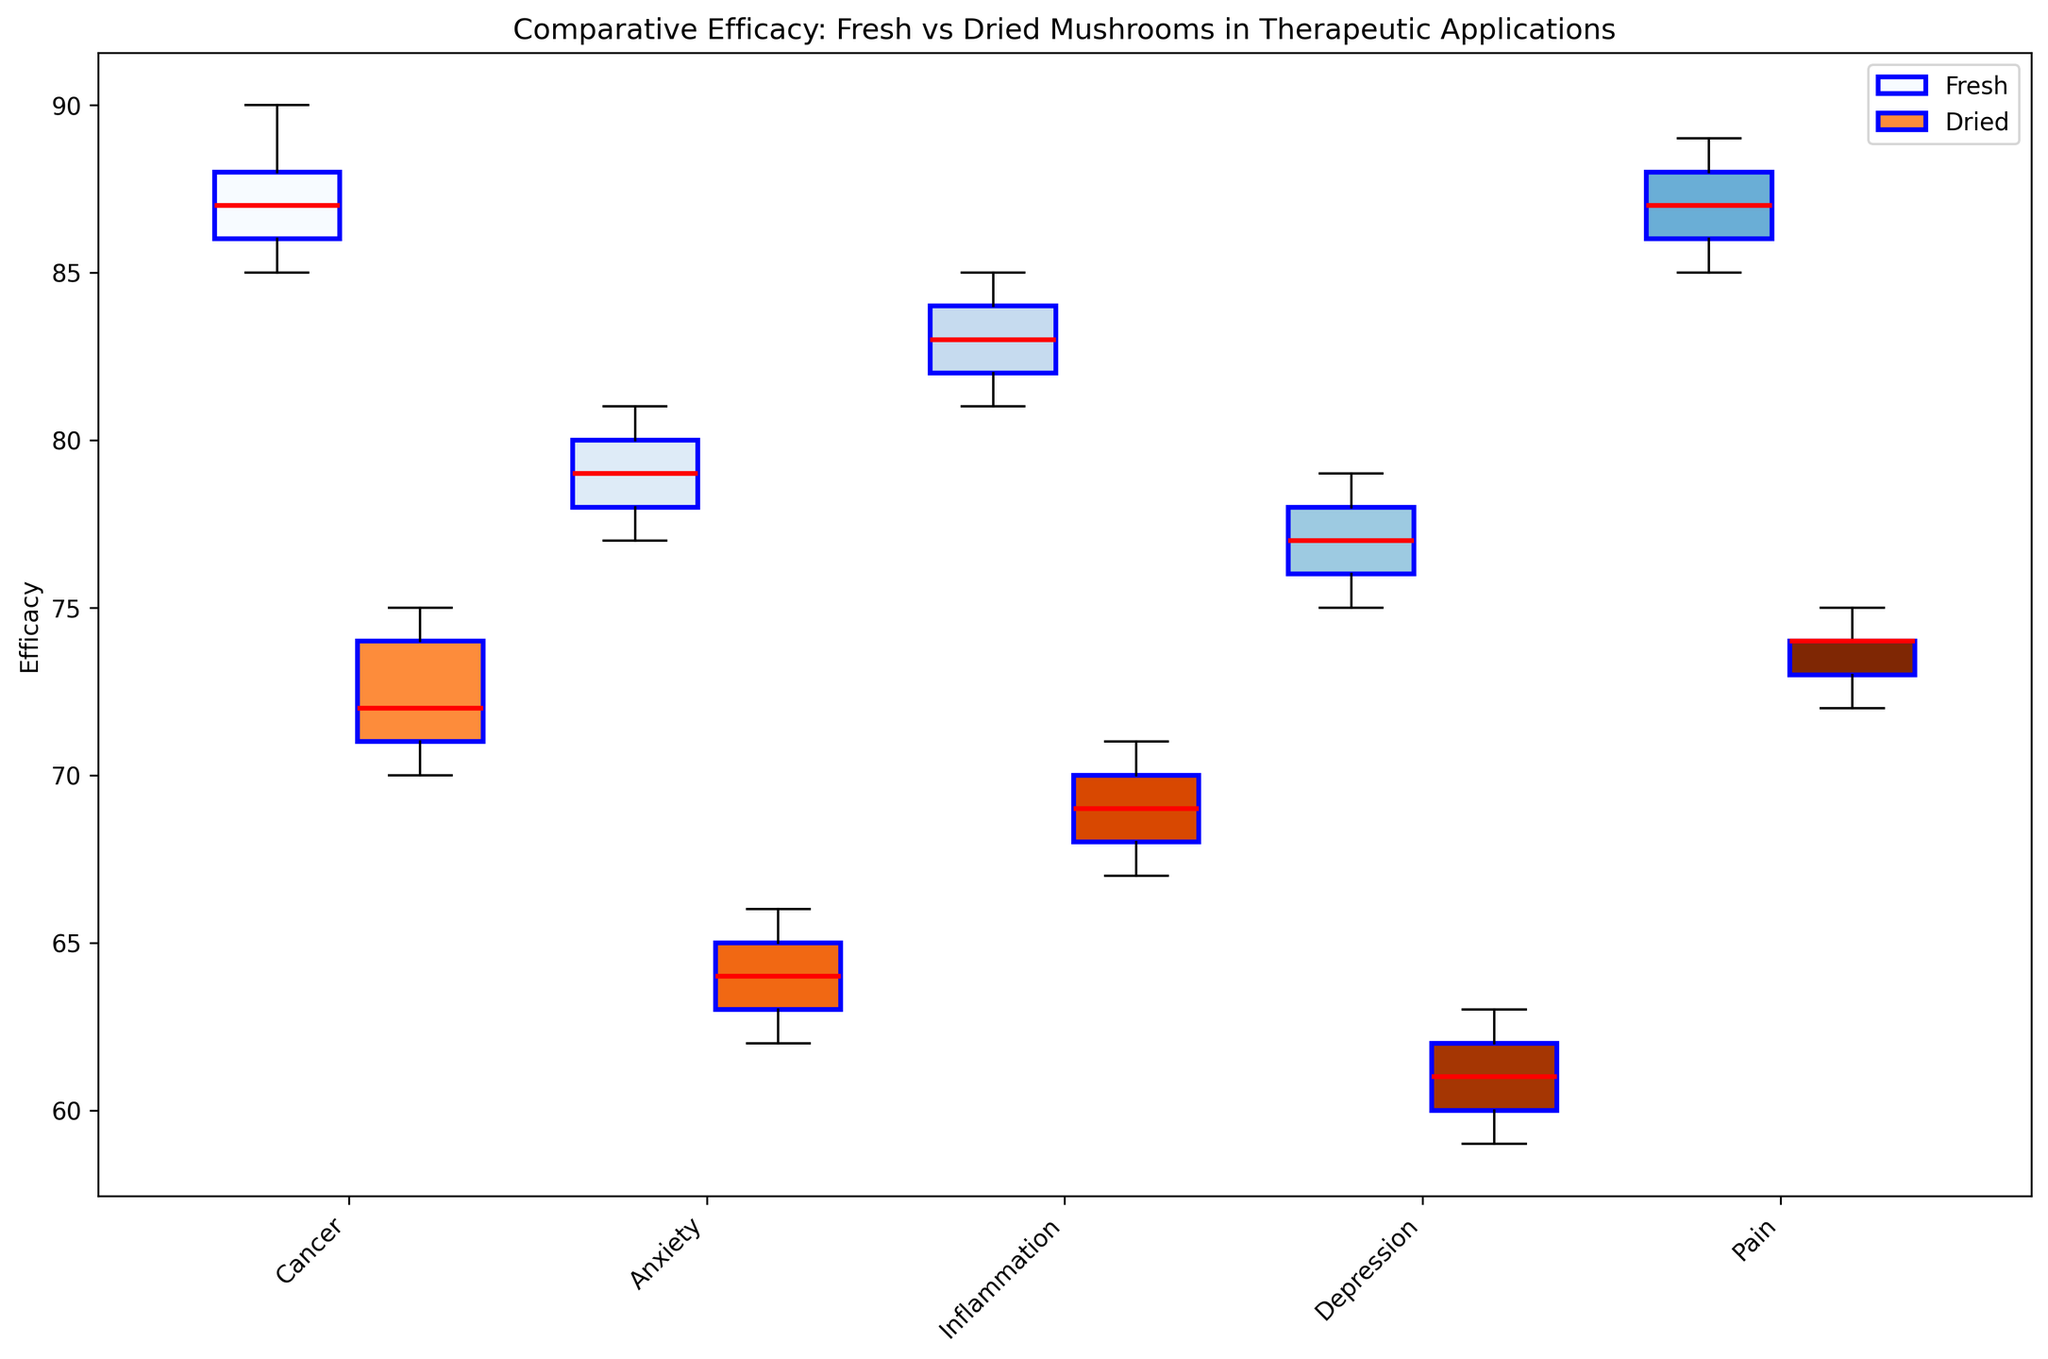What is the median efficacy value for fresh mushrooms in treating cancer? Look at the median line (red line) inside the box representing fresh mushrooms in the cancer treatment category.
Answer: 87 Which treatment shows a higher median efficacy for fresh mushrooms: anxiety or depression? Compare the median lines (red lines) inside the boxes for fresh mushrooms in both anxiety and depression categories.
Answer: Anxiety What is the range of the efficacy values for dried mushrooms in treating pain? Identify the lowest and highest points (whiskers) of the boxplot for dried mushrooms in the pain treatment category. Subtract the lowest value from the highest value.
Answer: 72 to 75 Which type of mushrooms (fresh or dried) has a more consistent efficacy in treating inflammation? Look at the spread of the whiskers and the interquartile range (the size of the boxes). A smaller range indicates higher consistency.
Answer: Fresh Compare the median efficacy values of fresh mushrooms in treating anxiety and inflammation. Which is higher, and by how much? Find the median lines (red lines) for both anxiety and inflammation in the fresh mushroom boxplots and subtract the lower one from the higher one.
Answer: Inflammation by 3 Which treatment method shows the widest interquartile range for dried mushrooms? The interquartile range is indicated by the length of the box. Compare the box lengths for the dried mushrooms across all treatment categories.
Answer: Cancer In which treatment category are fresh mushrooms more effective than dried mushrooms? For each treatment category, compare the medians (red lines) of fresh and dried mushroom boxplots.
Answer: All categories What is the efficacy range for fresh mushrooms in treating cancer? Identify the lowest and highest points (whiskers) of the boxplot for fresh mushrooms in the cancer treatment category. Subtract the lowest value from the highest value.
Answer: 85 to 90 Which type of mushrooms has the lowest median efficacy in treating depression, and what is its value? Compare the median lines (red lines) inside the boxes for fresh and dried mushrooms in the depression treatment category.
Answer: Dried, 61 What does the color scheme of the boxplots indicate? The color of the boxes differentiates fresh (blues) from dried (oranges) mushrooms.
Answer: Fresh (blue), Dried (orange) 